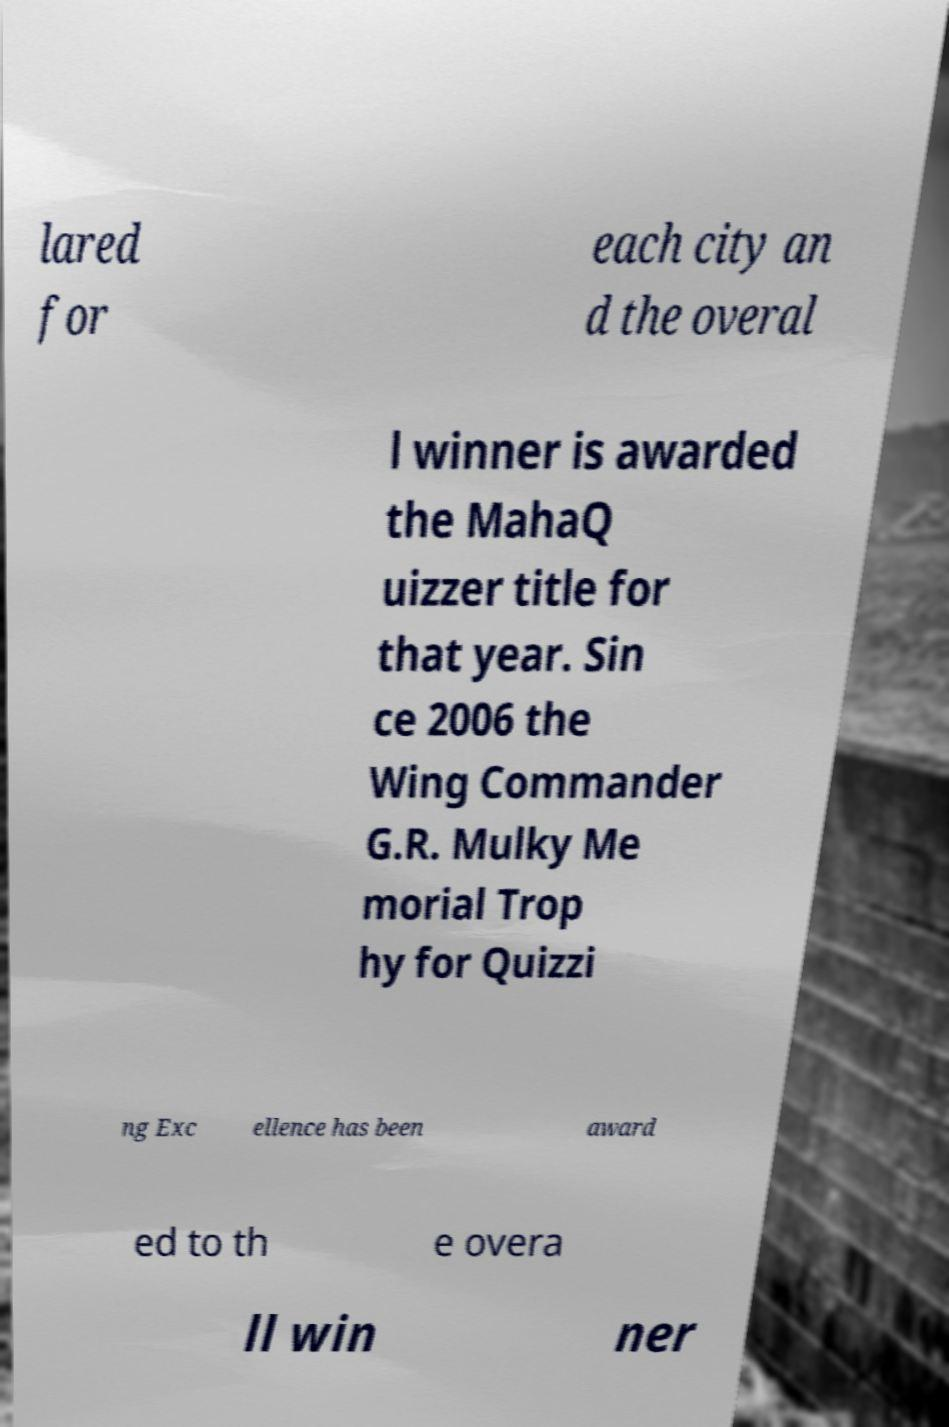Can you accurately transcribe the text from the provided image for me? lared for each city an d the overal l winner is awarded the MahaQ uizzer title for that year. Sin ce 2006 the Wing Commander G.R. Mulky Me morial Trop hy for Quizzi ng Exc ellence has been award ed to th e overa ll win ner 